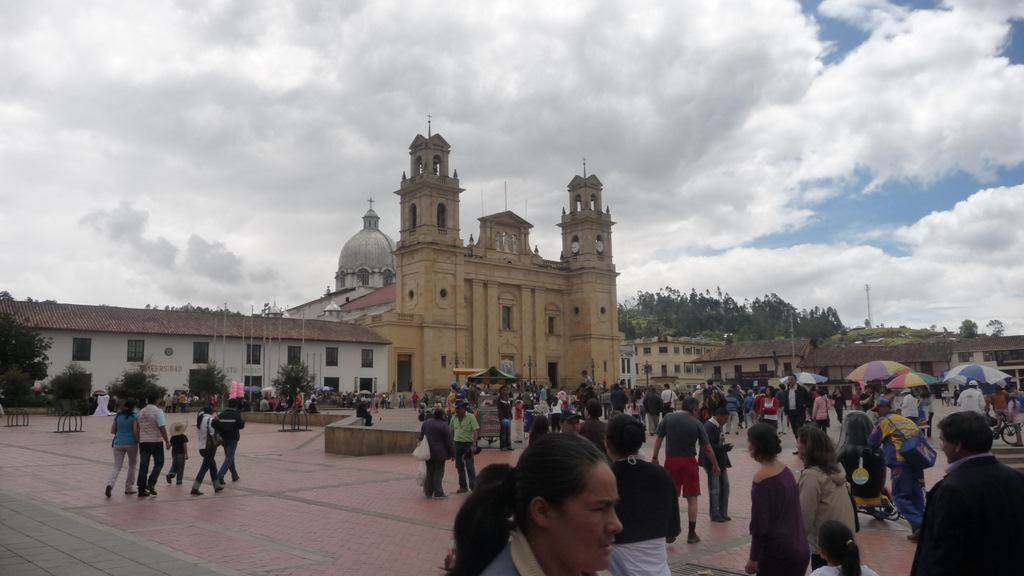What are the people in the image doing? The people in the image are walking. What structures can be seen in the image? There are tents, stalls, buildings, and a tower in the image. What type of vegetation is present in the image? There are plants and trees in the image. What are the poles used for in the image? The purpose of the poles in the image is not specified, but they could be used for various purposes such as supporting tents or signage. What is visible in the sky at the top of the image? There are clouds in the sky at the top of the image. What type of chain can be seen connecting the beef in the image? There is no chain or beef present in the image. How many wheels are visible on the stalls in the image? There is no information about wheels on the stalls in the image. 